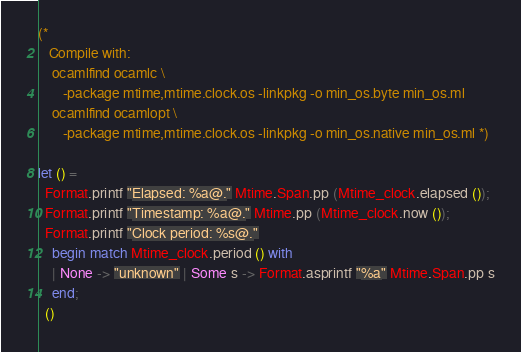<code> <loc_0><loc_0><loc_500><loc_500><_OCaml_>(*
   Compile with:
    ocamlfind ocamlc \
       -package mtime,mtime.clock.os -linkpkg -o min_os.byte min_os.ml
    ocamlfind ocamlopt \
       -package mtime,mtime.clock.os -linkpkg -o min_os.native min_os.ml *)

let () =
  Format.printf "Elapsed: %a@." Mtime.Span.pp (Mtime_clock.elapsed ());
  Format.printf "Timestamp: %a@." Mtime.pp (Mtime_clock.now ());
  Format.printf "Clock period: %s@."
    begin match Mtime_clock.period () with
    | None -> "unknown" | Some s -> Format.asprintf "%a" Mtime.Span.pp s
    end;
  ()
</code> 